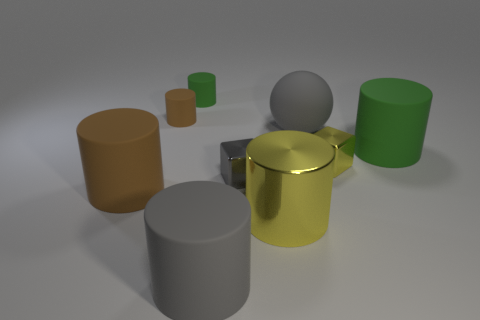Subtract all yellow cylinders. How many cylinders are left? 5 Subtract all small cylinders. How many cylinders are left? 4 Subtract all gray cylinders. Subtract all cyan spheres. How many cylinders are left? 5 Add 1 tiny metal cubes. How many objects exist? 10 Subtract all cylinders. How many objects are left? 3 Subtract 1 gray cubes. How many objects are left? 8 Subtract all small metal things. Subtract all small gray cubes. How many objects are left? 6 Add 8 large gray spheres. How many large gray spheres are left? 9 Add 5 large spheres. How many large spheres exist? 6 